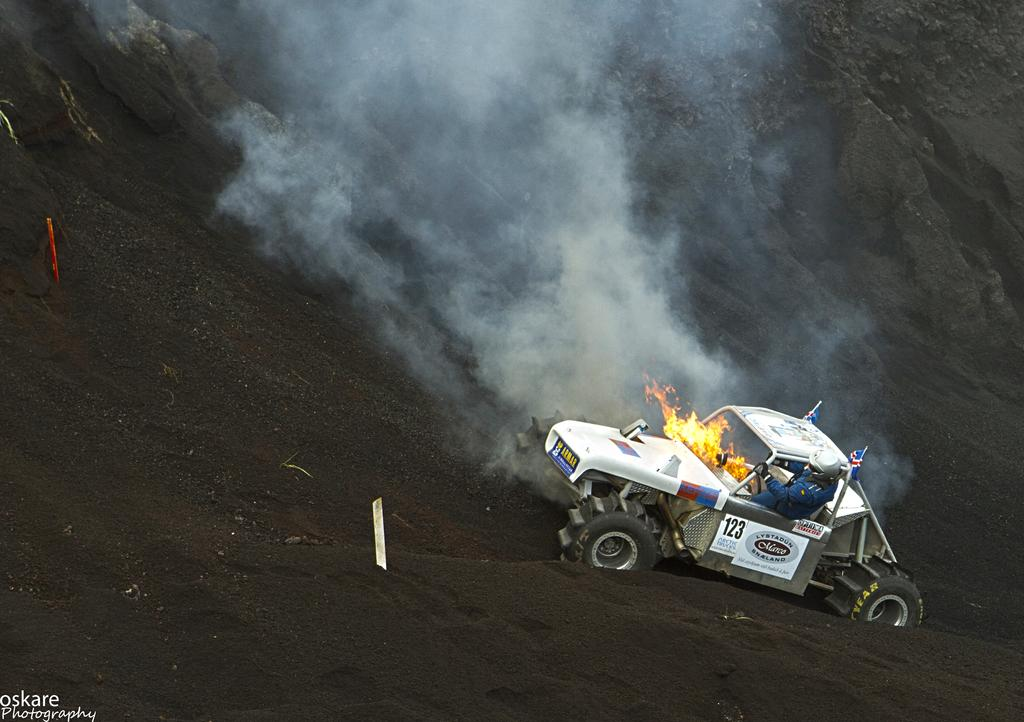What is the person in the image doing? There is a person driving a car in the image. What type of surface is the car being driven on? The car is being driven on the surface of the soil. How many jellyfish can be seen swimming in the car in the image? There are no jellyfish present in the car or the image. What type of fruit is being used as a steering wheel in the image? There is no fruit being used as a steering wheel in the image. 